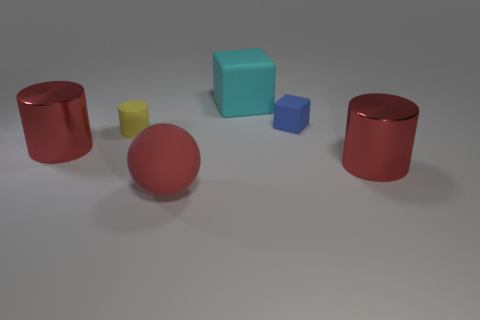Is there any other thing of the same color as the rubber sphere?
Your answer should be compact. Yes. What number of other objects have the same shape as the blue matte thing?
Your answer should be very brief. 1. There is a cylinder that is on the right side of the red rubber sphere; is it the same color as the matte ball?
Your response must be concise. Yes. The rubber object that is to the right of the tiny yellow thing and in front of the tiny matte cube is what color?
Your answer should be compact. Red. Is the material of the cylinder on the right side of the small yellow rubber object the same as the large cylinder left of the blue block?
Your response must be concise. Yes. There is a matte object in front of the yellow object; is its size the same as the big cyan rubber thing?
Your answer should be compact. Yes. There is a matte cylinder; is its color the same as the large metallic thing that is on the left side of the large cyan matte thing?
Provide a short and direct response. No. What is the shape of the tiny yellow thing?
Your answer should be very brief. Cylinder. Is the large matte cube the same color as the small block?
Your answer should be very brief. No. How many objects are small objects behind the rubber cylinder or big red objects?
Make the answer very short. 4. 